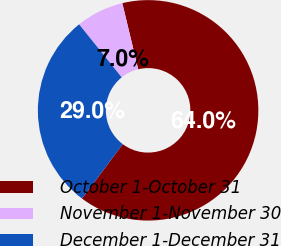Convert chart. <chart><loc_0><loc_0><loc_500><loc_500><pie_chart><fcel>October 1-October 31<fcel>November 1-November 30<fcel>December 1-December 31<nl><fcel>64.0%<fcel>7.0%<fcel>29.0%<nl></chart> 